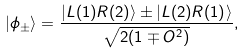Convert formula to latex. <formula><loc_0><loc_0><loc_500><loc_500>| \phi _ { \pm } \rangle = \frac { | { L ( 1 ) R ( 2 ) } \rangle \pm | { L ( 2 ) R ( 1 ) } \rangle } { \sqrt { 2 ( 1 \mp O ^ { 2 } ) } } ,</formula> 